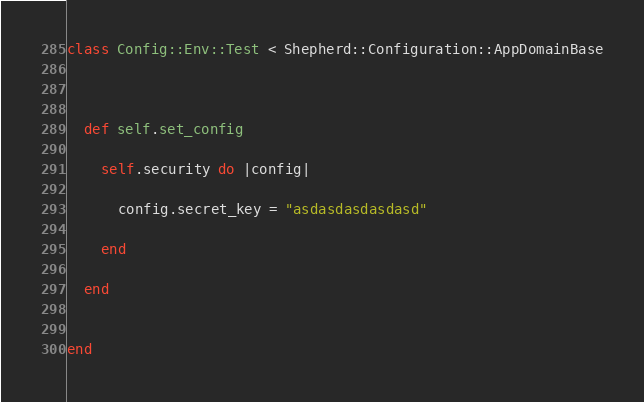<code> <loc_0><loc_0><loc_500><loc_500><_Crystal_>class Config::Env::Test < Shepherd::Configuration::AppDomainBase



  def self.set_config

    self.security do |config|

      config.secret_key = "asdasdasdasdasd"

    end

  end


end
</code> 